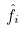<formula> <loc_0><loc_0><loc_500><loc_500>\hat { f } _ { i }</formula> 